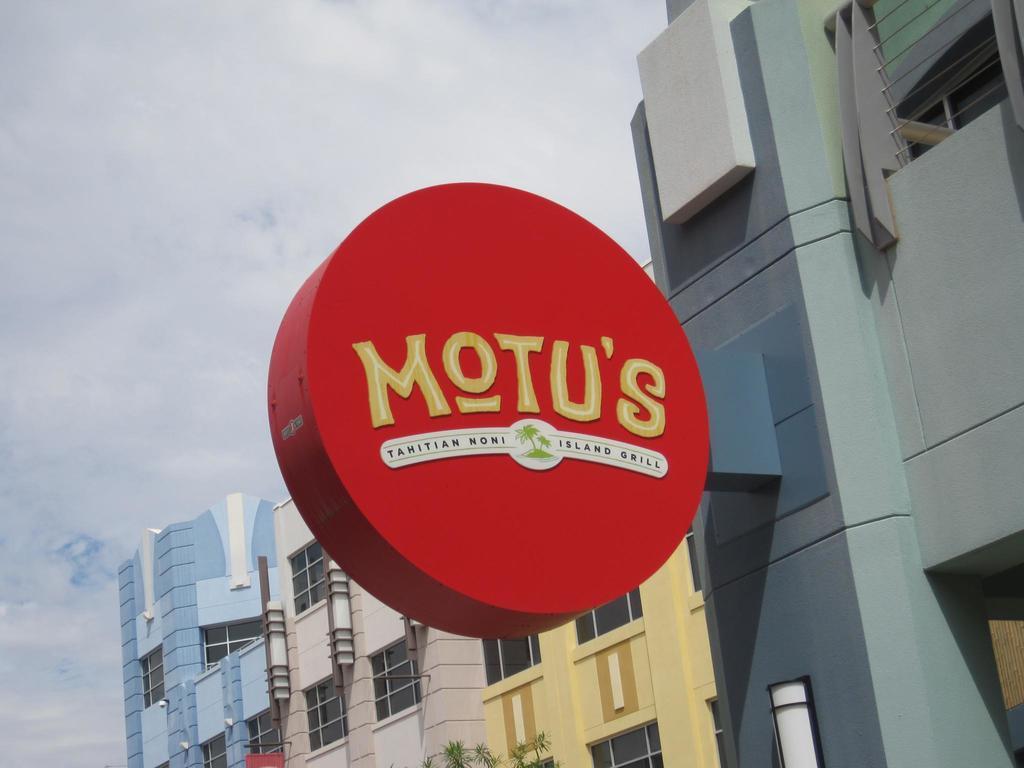Can you describe this image briefly? In this picture I can observe a red color board fixed to the wall of the building. I can observe some text on the board. In the background there are buildings and some clouds in the sky. 